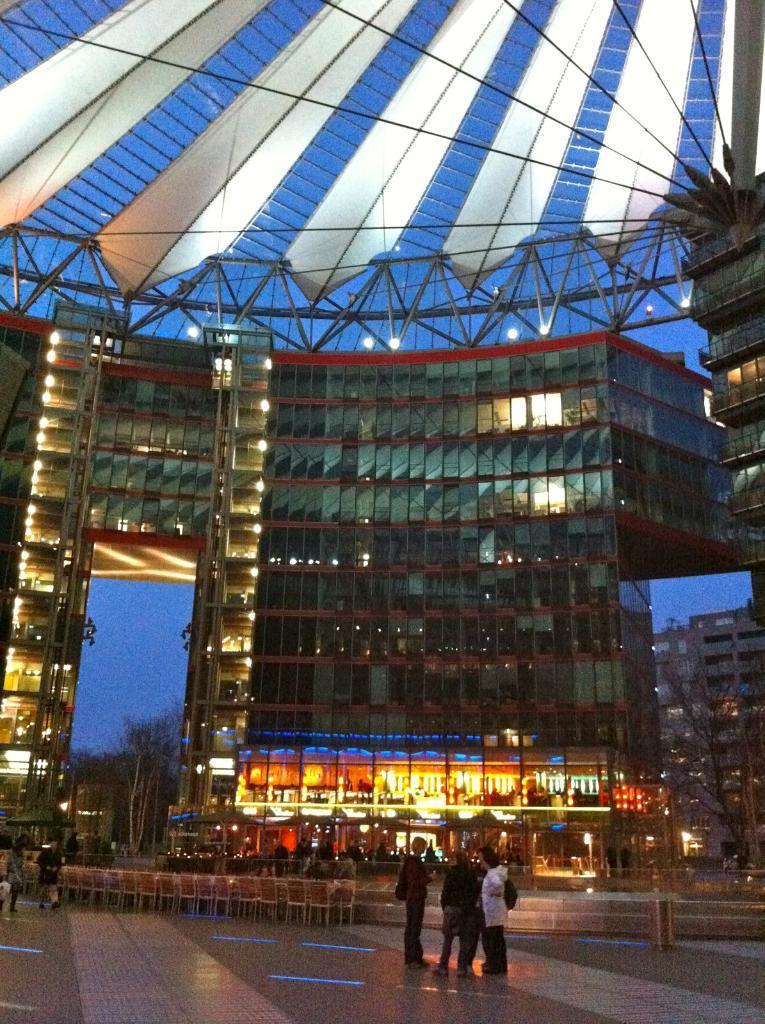Can you describe this image briefly? In this picture I can see there are few people standing and there are two people walking at left side, there are few chairs and buildings, it has glass windows. There is a iron frame on the roof and there are few trees, the sky is clear. 